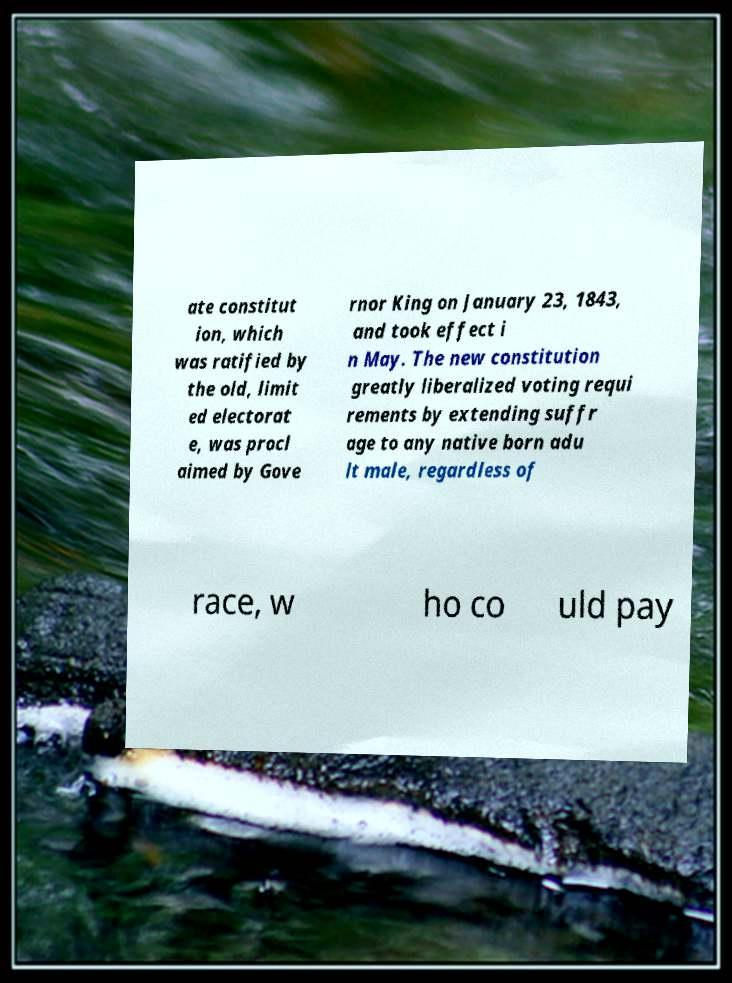Can you accurately transcribe the text from the provided image for me? ate constitut ion, which was ratified by the old, limit ed electorat e, was procl aimed by Gove rnor King on January 23, 1843, and took effect i n May. The new constitution greatly liberalized voting requi rements by extending suffr age to any native born adu lt male, regardless of race, w ho co uld pay 